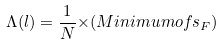<formula> <loc_0><loc_0><loc_500><loc_500>{ \Lambda } ( l ) = \frac { 1 } { N } { \times } ( M i n i m u m o f s _ { F } )</formula> 